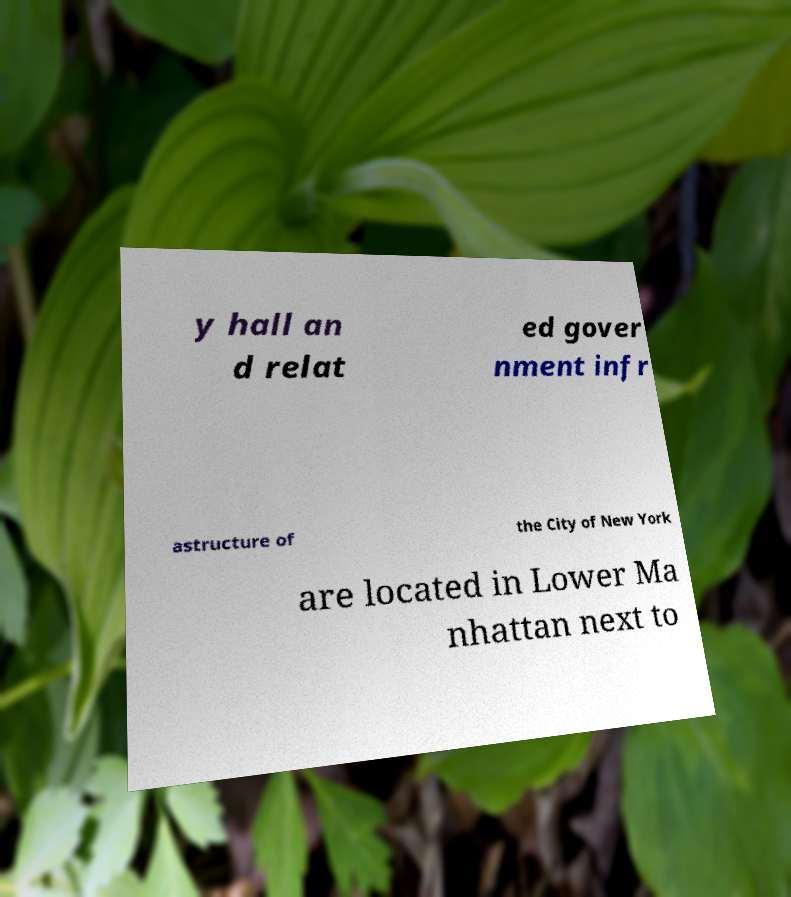Could you extract and type out the text from this image? y hall an d relat ed gover nment infr astructure of the City of New York are located in Lower Ma nhattan next to 